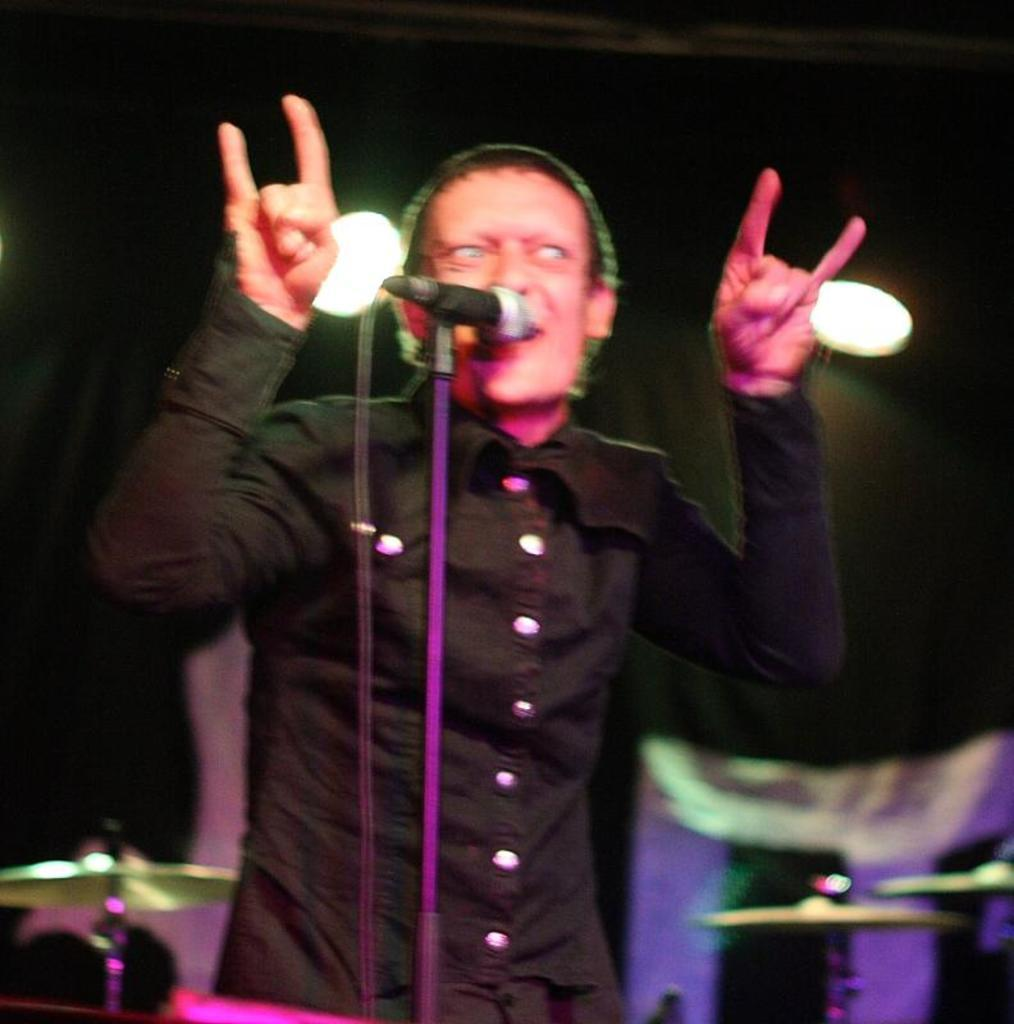What is the man in the image doing? The man is standing in the image. What object is in front of the man? There is a microphone in front of the man. How is the microphone positioned? The microphone has a stand. What can be seen in the background of the image? There are cymbals and a wall in the background of the image. What is the source of light in the image? There is light behind the man. What type of van can be seen parked next to the wall in the image? There is no van present in the image; only a man, a microphone, a stand, cymbals, a wall, and a light source are visible. 